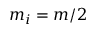<formula> <loc_0><loc_0><loc_500><loc_500>m _ { i } = m / 2</formula> 